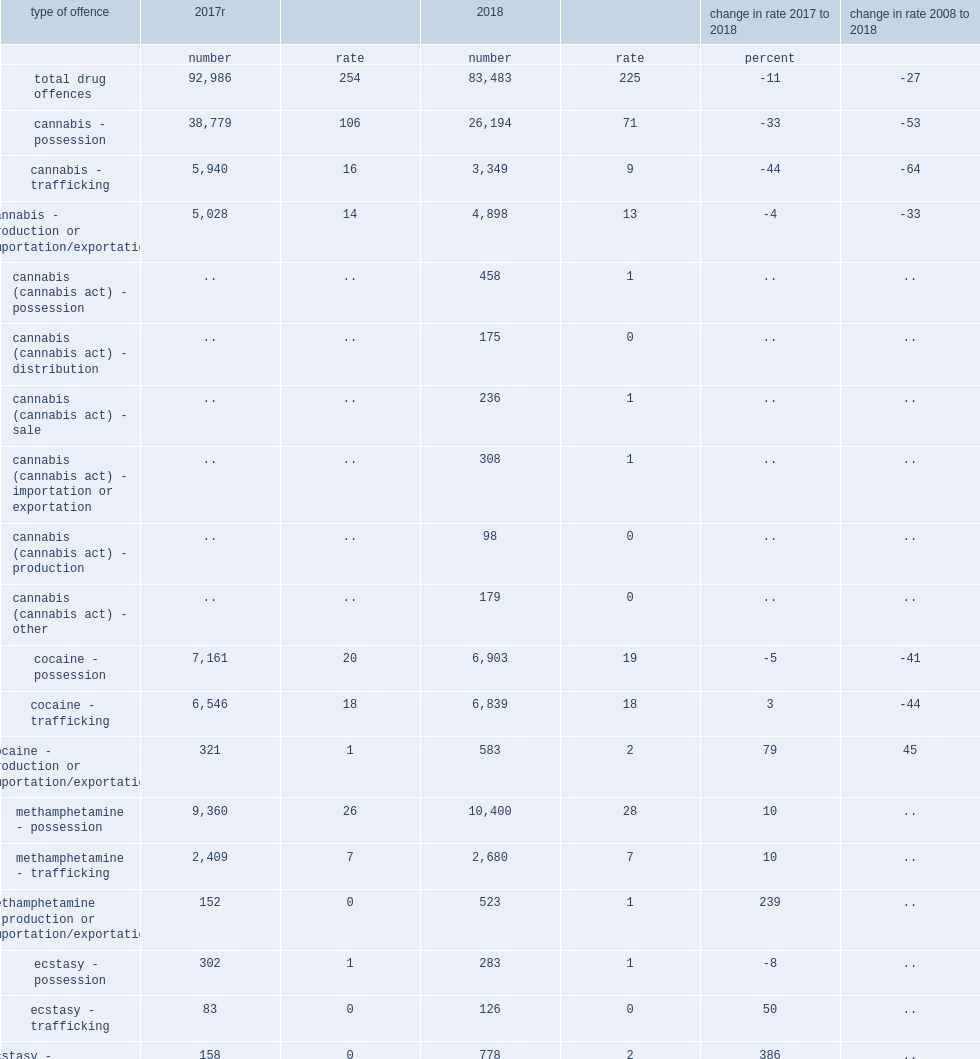Overall in 2018, how many cdsa and cannabis act offences reported by police? 83483.0. Overall in 2018, what a rate per 100,000 population did cdsa and cannabis act offences reported by police represent? 225.0. 